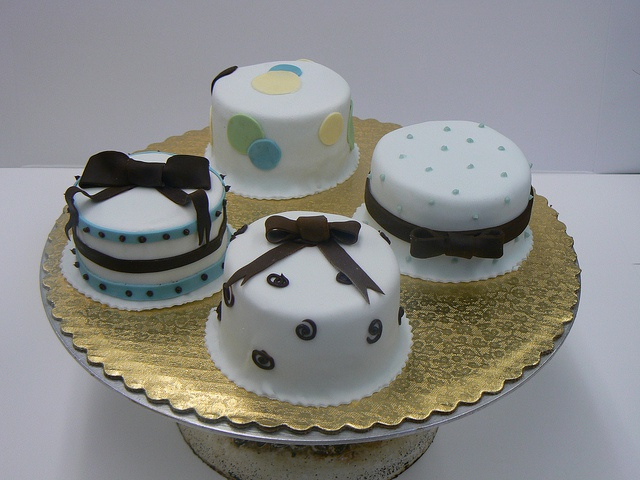Describe the objects in this image and their specific colors. I can see bowl in gray, darkgray, black, and olive tones, cake in gray, darkgray, and black tones, cake in gray, lightgray, darkgray, and black tones, cake in gray, black, and darkgray tones, and cake in gray, darkgray, and lightgray tones in this image. 